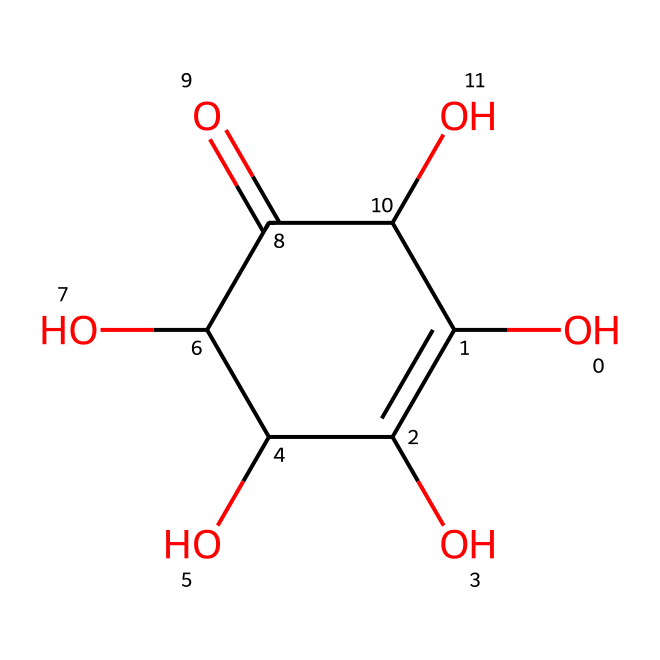How many hydroxyl groups are present in ascorbic acid? The SMILES representation shows multiple -OH (hydroxyl) groups attached to carbon atoms. Counting the -OH groups in the structure reveals there are four hydroxyl groups.
Answer: four What is the molecular weight of ascorbic acid? To determine the molecular weight, we can analyze the chemical formula derived from the SMILES. Ascorbic acid has the formula C6H8O6, and calculating the molecular weight using atomic masses (C: 12, H: 1, O: 16) gives 176.12 g/mol.
Answer: 176.12 What functional groups are present in this structure? Looking at the SMILES, we can identify the presence of hydroxyl (-OH) groups and a carbonyl (C=O) group, which are characteristic of alcohols and ketones.
Answer: hydroxyl and carbonyl How is ascorbic acid categorized in terms of its chemical properties? Ascorbic acid contains multiple hydroxyl groups, a characteristic that categorizes it as a polyol. It also acts as a reducing agent due to the presence of its easily oxidizable carbon atoms.
Answer: polyol Which part of the molecule contributes to its antioxidant properties? The antioxidant properties are primarily due to the hydroxyl groups, which can donate electrons to free radicals, thus neutralizing them and preventing oxidative damage.
Answer: hydroxyl groups What structural elements enable the solubility of ascorbic acid in water? The presence of multiple hydroxyl groups increases the polarity of the molecule, allowing it to interact favorably with water, making it soluble.
Answer: hydroxyl groups 